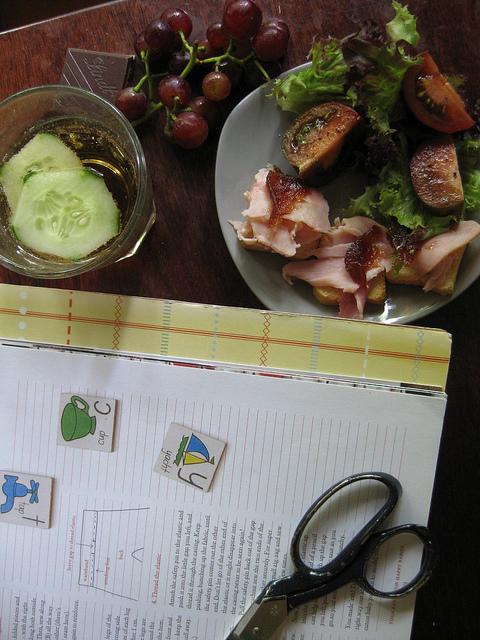What color is the handle on the scissors?
Give a very brief answer. Black. What is in the clear glass?
Keep it brief. Cucumber. Are the scissors open or shut?
Be succinct. Shut. Which item in this picture could be a weapon?
Be succinct. Scissors. 